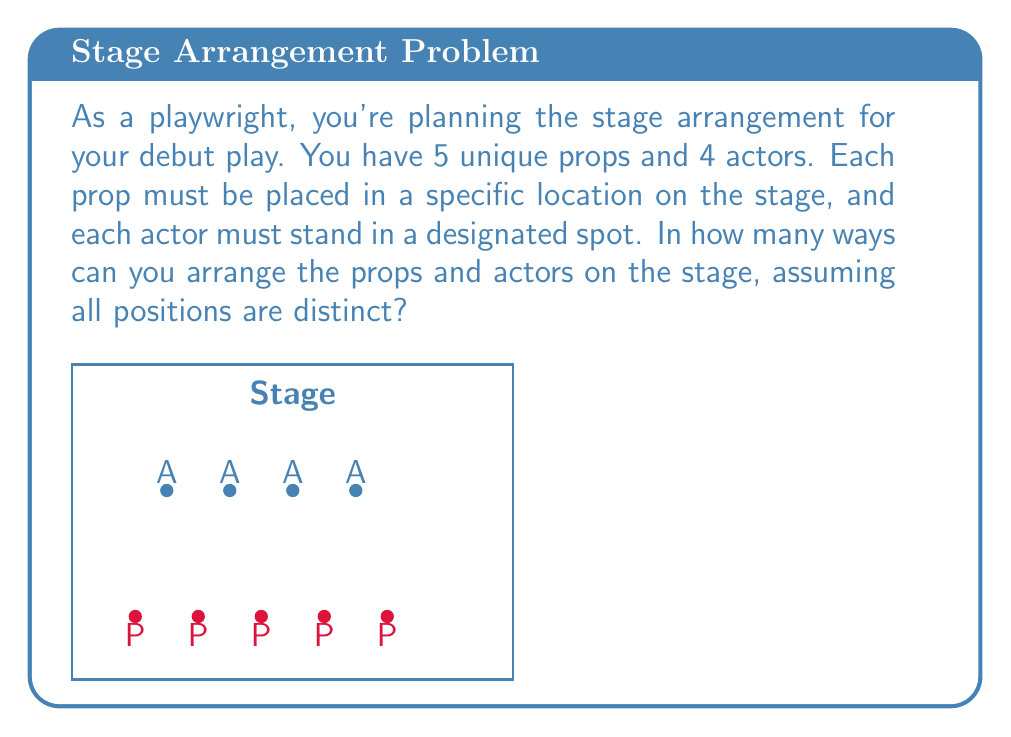Provide a solution to this math problem. Let's approach this step-by-step:

1) First, we need to understand that this is a permutation problem. We're arranging both props and actors in specific positions.

2) For the props:
   - We have 5 props to arrange in 5 positions.
   - This is a straightforward permutation: $P(5,5) = 5!$

3) For the actors:
   - We have 4 actors to arrange in 4 positions.
   - This is also a permutation: $P(4,4) = 4!$

4) Now, according to the multiplication principle, if we have $m$ ways of doing one thing and $n$ ways of doing another thing, there are $m \times n$ ways of doing both things.

5) Therefore, the total number of ways to arrange both props and actors is:

   $5! \times 4!$

6) Let's calculate this:
   $5! \times 4! = (5 \times 4 \times 3 \times 2 \times 1) \times (4 \times 3 \times 2 \times 1)$
   $= 120 \times 24 = 2880$

Thus, there are 2880 different ways to arrange the props and actors on the stage.
Answer: 2880 